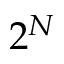Convert formula to latex. <formula><loc_0><loc_0><loc_500><loc_500>2 ^ { N }</formula> 